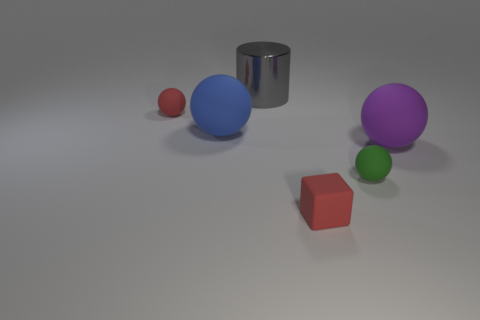Are there any other things that are made of the same material as the big gray object?
Give a very brief answer. No. Do the small matte object on the left side of the big blue object and the rubber block have the same color?
Your answer should be very brief. Yes. What material is the tiny object that is the same color as the tiny cube?
Make the answer very short. Rubber. What number of other things are there of the same color as the small rubber cube?
Offer a terse response. 1. What number of other things are the same material as the small block?
Offer a very short reply. 4. Are there any tiny spheres behind the big rubber ball that is to the left of the tiny ball in front of the big purple object?
Offer a very short reply. Yes. Is the material of the gray cylinder the same as the blue sphere?
Give a very brief answer. No. Is there anything else that is the same shape as the green rubber thing?
Keep it short and to the point. Yes. There is a object in front of the tiny matte ball on the right side of the red rubber block; what is it made of?
Offer a terse response. Rubber. There is a red rubber object that is in front of the big blue object; what is its size?
Offer a terse response. Small. 